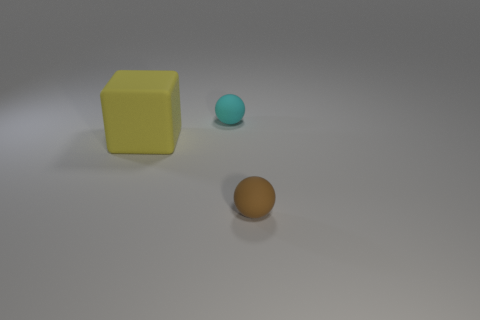Add 2 metallic cylinders. How many objects exist? 5 Subtract all balls. How many objects are left? 1 Add 1 rubber balls. How many rubber balls are left? 3 Add 2 big blue objects. How many big blue objects exist? 2 Subtract 0 green cylinders. How many objects are left? 3 Subtract all brown matte spheres. Subtract all yellow rubber things. How many objects are left? 1 